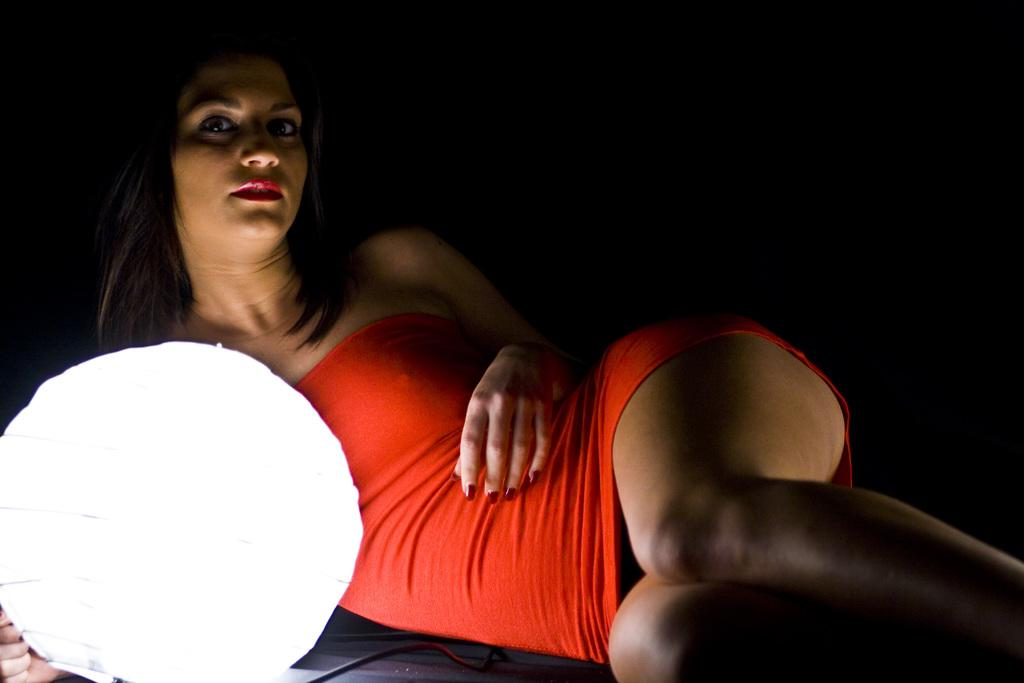What is the woman doing in the image? The woman is laying on the floor in the image. What is the woman wearing in the image? The woman is wearing a red color dress in the image. What object is in front of the woman in the image? There is a white color lamp in front of the woman in the image. How would you describe the background of the image? The background of the image is dark. Can you see a flame touching the woman's dress in the image? No, there is no flame present in the image, and it is not touching the woman's dress. What scientific theory is being demonstrated in the image? There is no scientific theory being demonstrated in the image; it simply shows a woman laying on the floor with a lamp in front of her. 